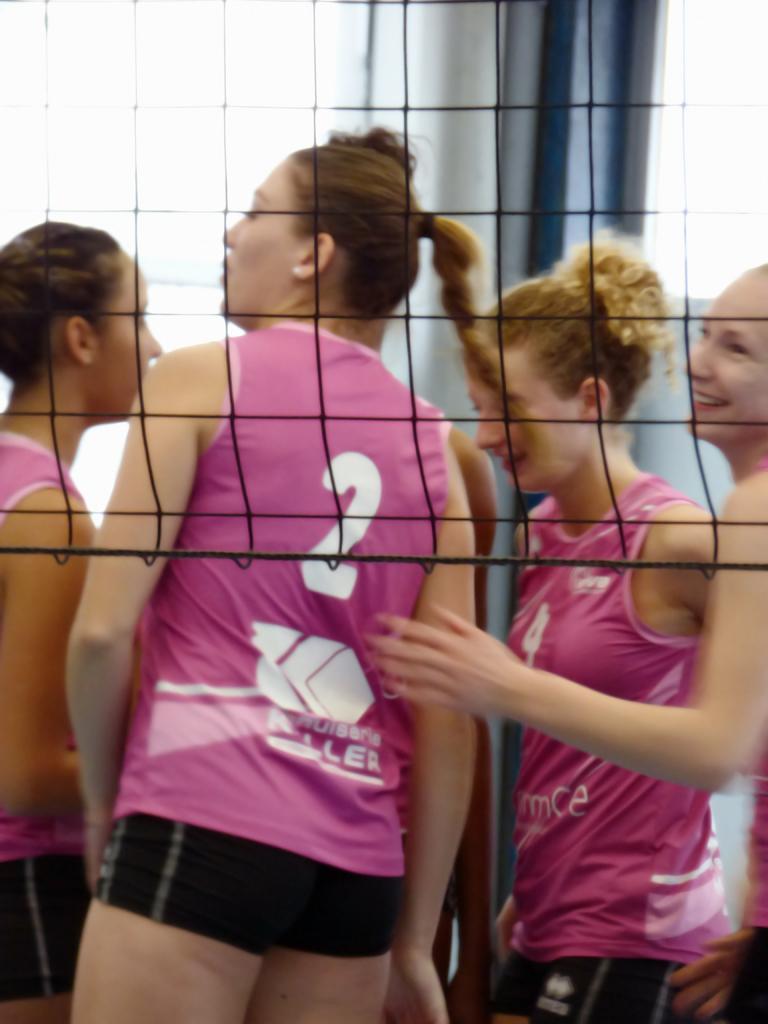Describe this image in one or two sentences. In this image we can see women standing through a sports net. 